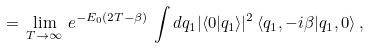Convert formula to latex. <formula><loc_0><loc_0><loc_500><loc_500>\, = \, \lim _ { T \to \infty } \, e ^ { - E _ { 0 } ( 2 T - \beta ) } \, \int d q _ { 1 } | \langle 0 | q _ { 1 } \rangle | ^ { 2 } \, \langle q _ { 1 } , - i \beta | q _ { 1 } , 0 \rangle \, ,</formula> 